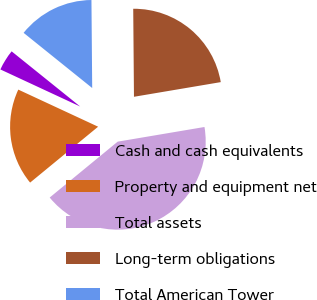Convert chart. <chart><loc_0><loc_0><loc_500><loc_500><pie_chart><fcel>Cash and cash equivalents<fcel>Property and equipment net<fcel>Total assets<fcel>Long-term obligations<fcel>Total American Tower<nl><fcel>3.86%<fcel>17.87%<fcel>41.71%<fcel>22.47%<fcel>14.08%<nl></chart> 